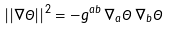Convert formula to latex. <formula><loc_0><loc_0><loc_500><loc_500>| | \nabla \Theta | | ^ { 2 } = - g ^ { a b } \, \nabla _ { a } \Theta \, \nabla _ { b } \Theta</formula> 